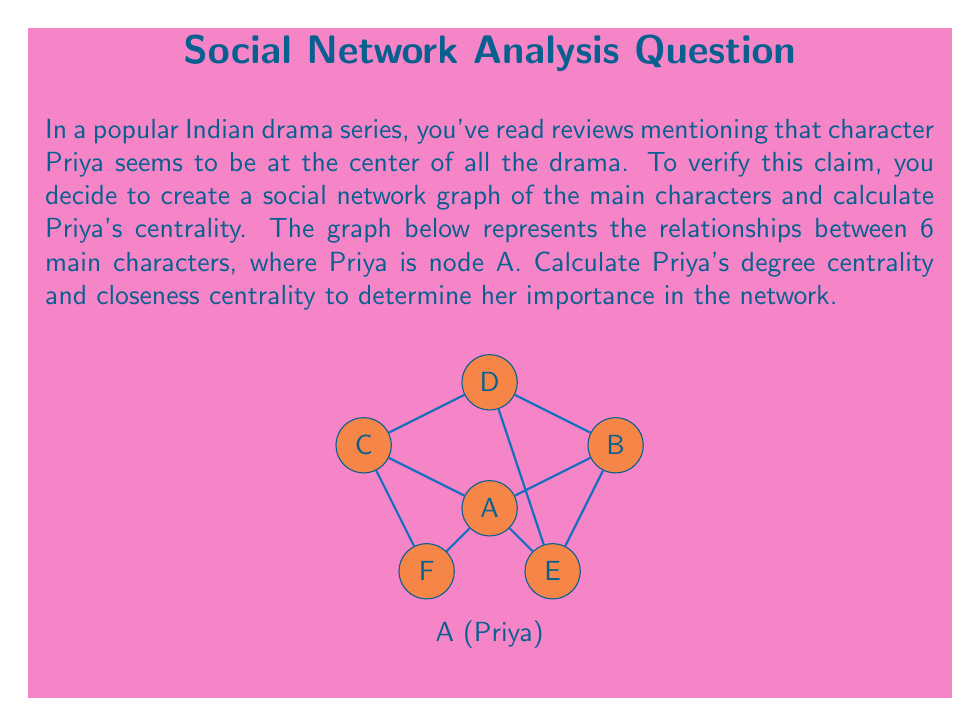Can you answer this question? Let's calculate Priya's (node A) degree centrality and closeness centrality step by step:

1. Degree Centrality:
   Degree centrality is the number of direct connections a node has.
   Priya (A) is directly connected to B, C, E, and F.
   Degree centrality = 4
   Normalized degree centrality = $\frac{4}{5} = 0.8$ (since there are 6 nodes in total, max possible connections is 5)

2. Closeness Centrality:
   Closeness centrality measures how close a node is to all other nodes in the network.
   
   First, calculate the shortest path from A to all other nodes:
   A to B: 1
   A to C: 1
   A to D: 2
   A to E: 1
   A to F: 1
   
   Sum of shortest paths = 1 + 1 + 2 + 1 + 1 = 6
   
   Closeness centrality = $\frac{1}{\text{sum of shortest paths}} = \frac{1}{6}$
   
   Normalized closeness centrality = $\frac{n-1}{\text{sum of shortest paths}} = \frac{5}{6} \approx 0.833$
   where n is the number of nodes in the network.

Both centrality measures indicate that Priya (A) is indeed central to the network, supporting the reviews you've read about her importance in the drama.
Answer: Degree centrality: 0.8; Closeness centrality: 0.833 